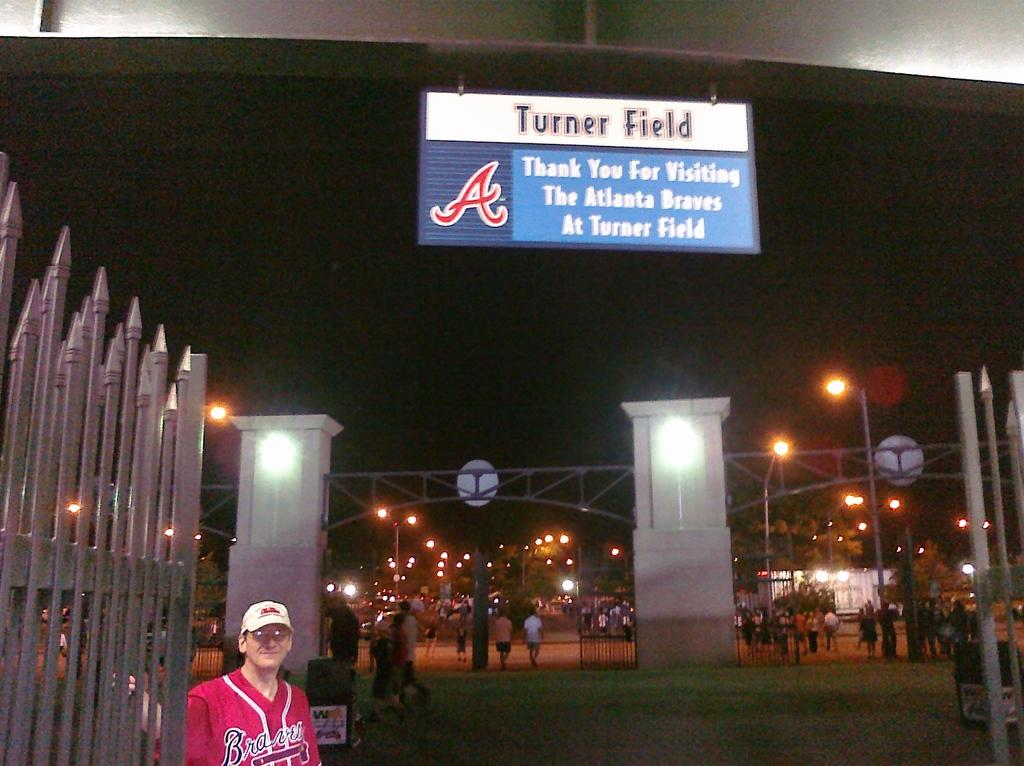<image>
Share a concise interpretation of the image provided. Atlanta Braves at Turner Field is advertised on the sign hanging above. 